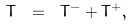Convert formula to latex. <formula><loc_0><loc_0><loc_500><loc_500>T \ = \ T ^ { - } + T ^ { + } ,</formula> 